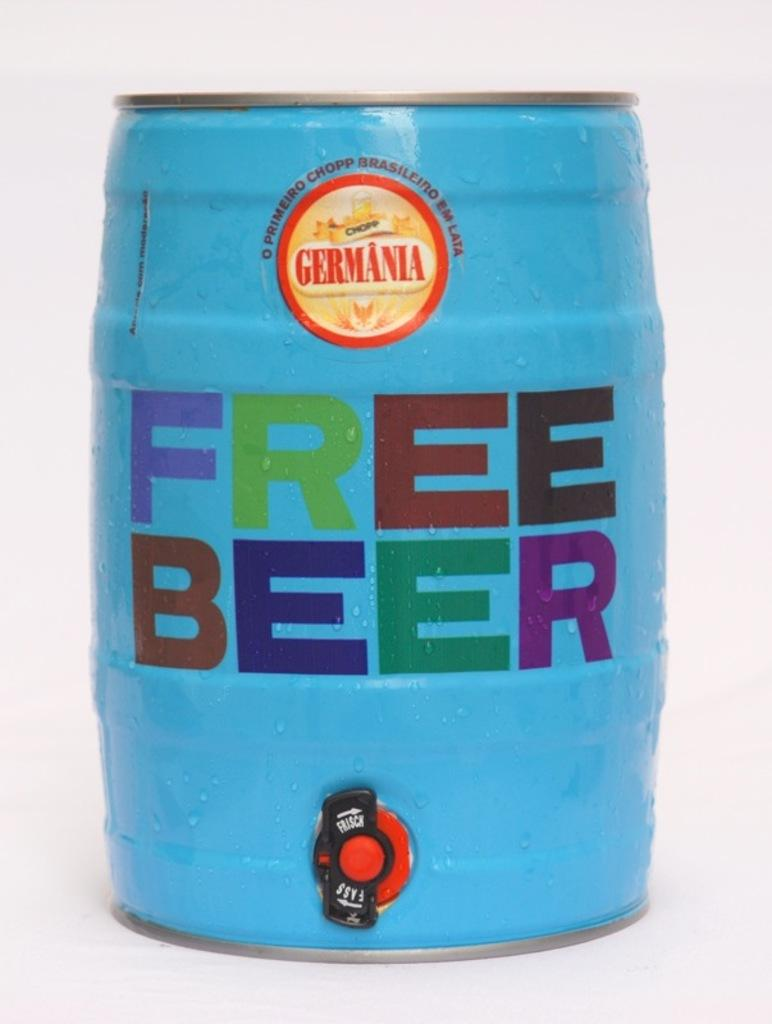<image>
Share a concise interpretation of the image provided. A blue mini keg says free beer in big, bright, and bold letters on the front. 